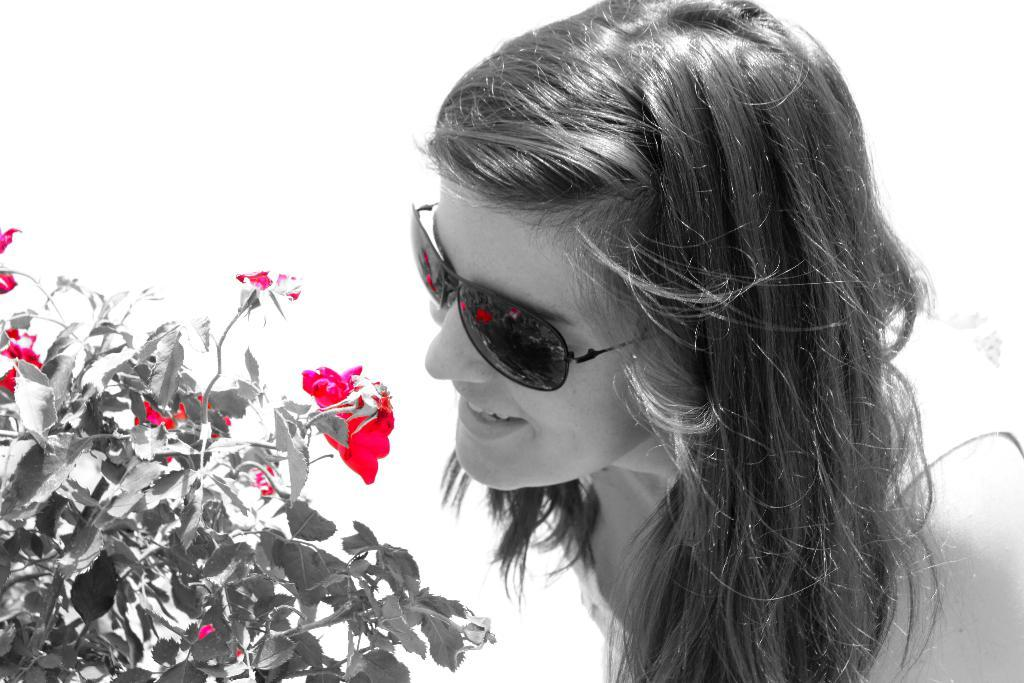What is the main subject of the image? The main subject of the image is a woman. What is the woman wearing in the image? The woman is wearing goggles in the image. What is the woman facing in the image? The woman is facing a rose plant in the image. What type of produce can be seen growing on the woman's hands in the image? There is no produce visible on the woman's hands in the image. Can you tell me where the woman is located based on a map in the image? There is no map present in the image. What type of winter clothing is the woman wearing in the image? The woman is not wearing any winter clothing, such as mittens, in the image. 